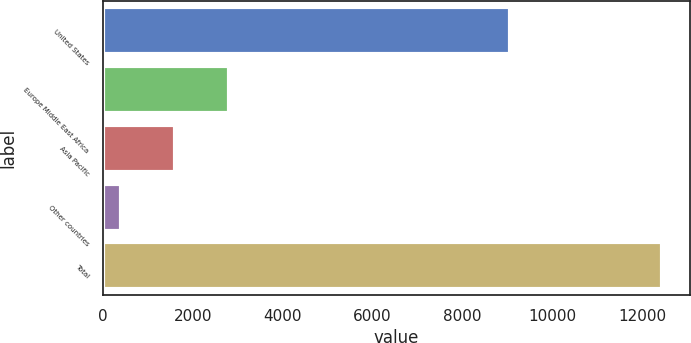<chart> <loc_0><loc_0><loc_500><loc_500><bar_chart><fcel>United States<fcel>Europe Middle East Africa<fcel>Asia Pacific<fcel>Other countries<fcel>Total<nl><fcel>9059<fcel>2812.8<fcel>1608.9<fcel>405<fcel>12444<nl></chart> 